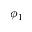Convert formula to latex. <formula><loc_0><loc_0><loc_500><loc_500>\phi _ { 1 }</formula> 